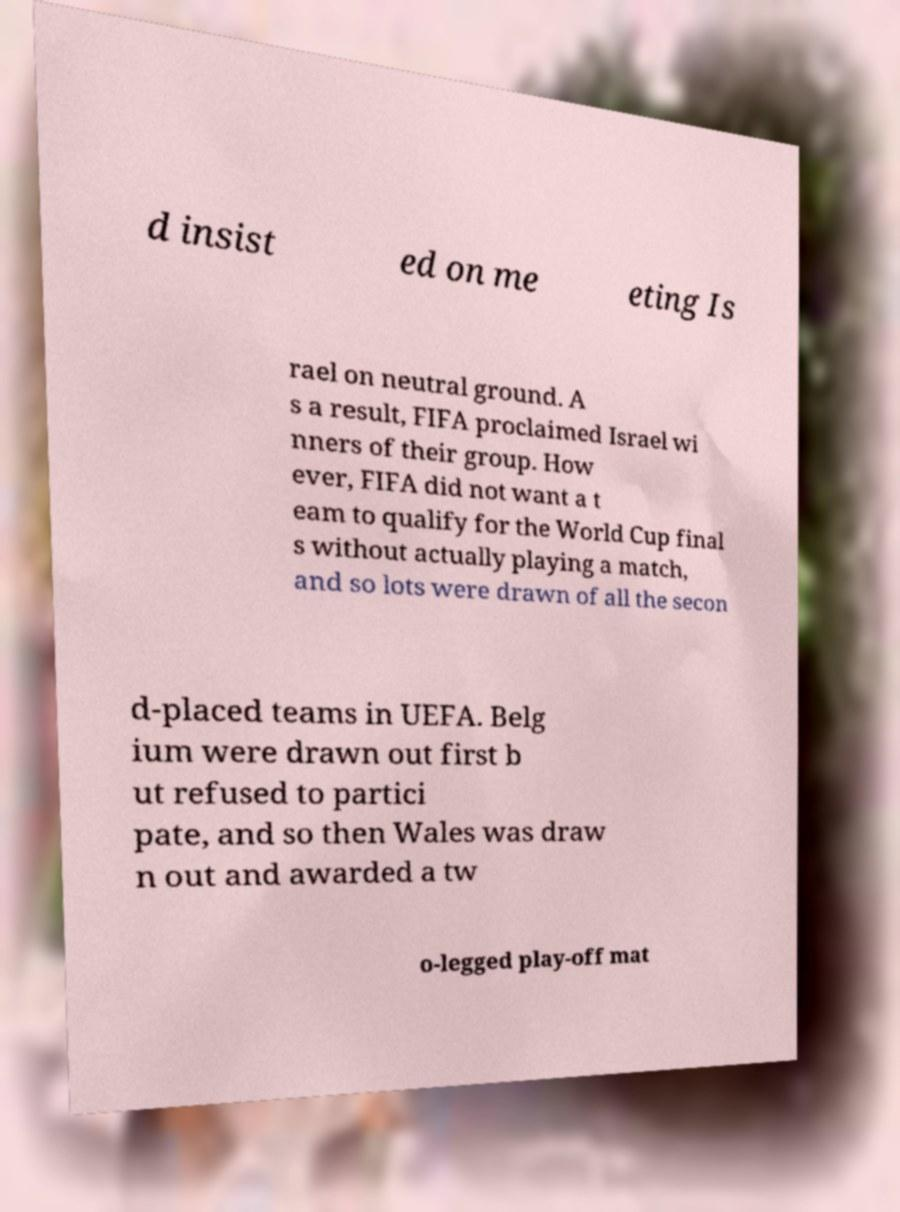There's text embedded in this image that I need extracted. Can you transcribe it verbatim? d insist ed on me eting Is rael on neutral ground. A s a result, FIFA proclaimed Israel wi nners of their group. How ever, FIFA did not want a t eam to qualify for the World Cup final s without actually playing a match, and so lots were drawn of all the secon d-placed teams in UEFA. Belg ium were drawn out first b ut refused to partici pate, and so then Wales was draw n out and awarded a tw o-legged play-off mat 